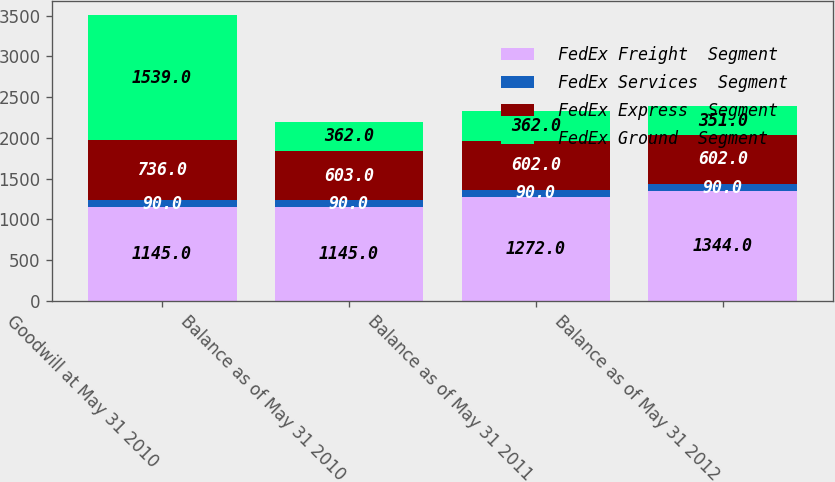Convert chart. <chart><loc_0><loc_0><loc_500><loc_500><stacked_bar_chart><ecel><fcel>Goodwill at May 31 2010<fcel>Balance as of May 31 2010<fcel>Balance as of May 31 2011<fcel>Balance as of May 31 2012<nl><fcel>FedEx Freight  Segment<fcel>1145<fcel>1145<fcel>1272<fcel>1344<nl><fcel>FedEx Services  Segment<fcel>90<fcel>90<fcel>90<fcel>90<nl><fcel>FedEx Express  Segment<fcel>736<fcel>603<fcel>602<fcel>602<nl><fcel>FedEx Ground  Segment<fcel>1539<fcel>362<fcel>362<fcel>351<nl></chart> 